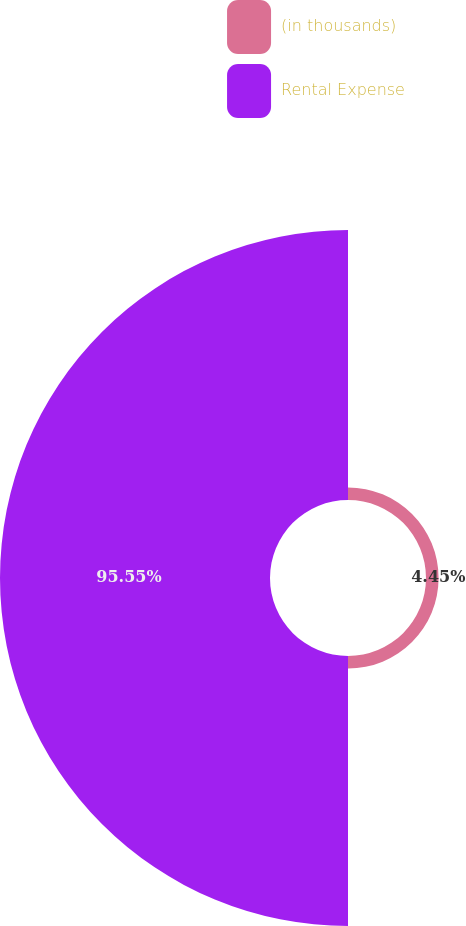Convert chart. <chart><loc_0><loc_0><loc_500><loc_500><pie_chart><fcel>(in thousands)<fcel>Rental Expense<nl><fcel>4.45%<fcel>95.55%<nl></chart> 